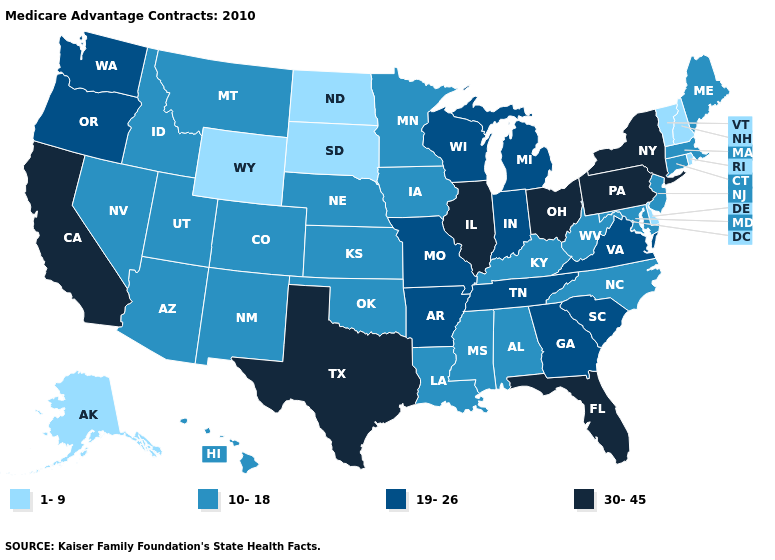What is the highest value in states that border Tennessee?
Write a very short answer. 19-26. Name the states that have a value in the range 1-9?
Answer briefly. Alaska, Delaware, North Dakota, New Hampshire, Rhode Island, South Dakota, Vermont, Wyoming. Name the states that have a value in the range 30-45?
Concise answer only. California, Florida, Illinois, New York, Ohio, Pennsylvania, Texas. What is the value of Alabama?
Give a very brief answer. 10-18. What is the highest value in the USA?
Keep it brief. 30-45. Which states have the lowest value in the South?
Keep it brief. Delaware. Does the first symbol in the legend represent the smallest category?
Concise answer only. Yes. Does Kentucky have the highest value in the South?
Keep it brief. No. Among the states that border Georgia , does Florida have the highest value?
Give a very brief answer. Yes. Name the states that have a value in the range 1-9?
Concise answer only. Alaska, Delaware, North Dakota, New Hampshire, Rhode Island, South Dakota, Vermont, Wyoming. What is the value of Massachusetts?
Write a very short answer. 10-18. Does the first symbol in the legend represent the smallest category?
Short answer required. Yes. Name the states that have a value in the range 10-18?
Quick response, please. Alabama, Arizona, Colorado, Connecticut, Hawaii, Iowa, Idaho, Kansas, Kentucky, Louisiana, Massachusetts, Maryland, Maine, Minnesota, Mississippi, Montana, North Carolina, Nebraska, New Jersey, New Mexico, Nevada, Oklahoma, Utah, West Virginia. Which states have the lowest value in the USA?
Write a very short answer. Alaska, Delaware, North Dakota, New Hampshire, Rhode Island, South Dakota, Vermont, Wyoming. What is the value of Illinois?
Be succinct. 30-45. 